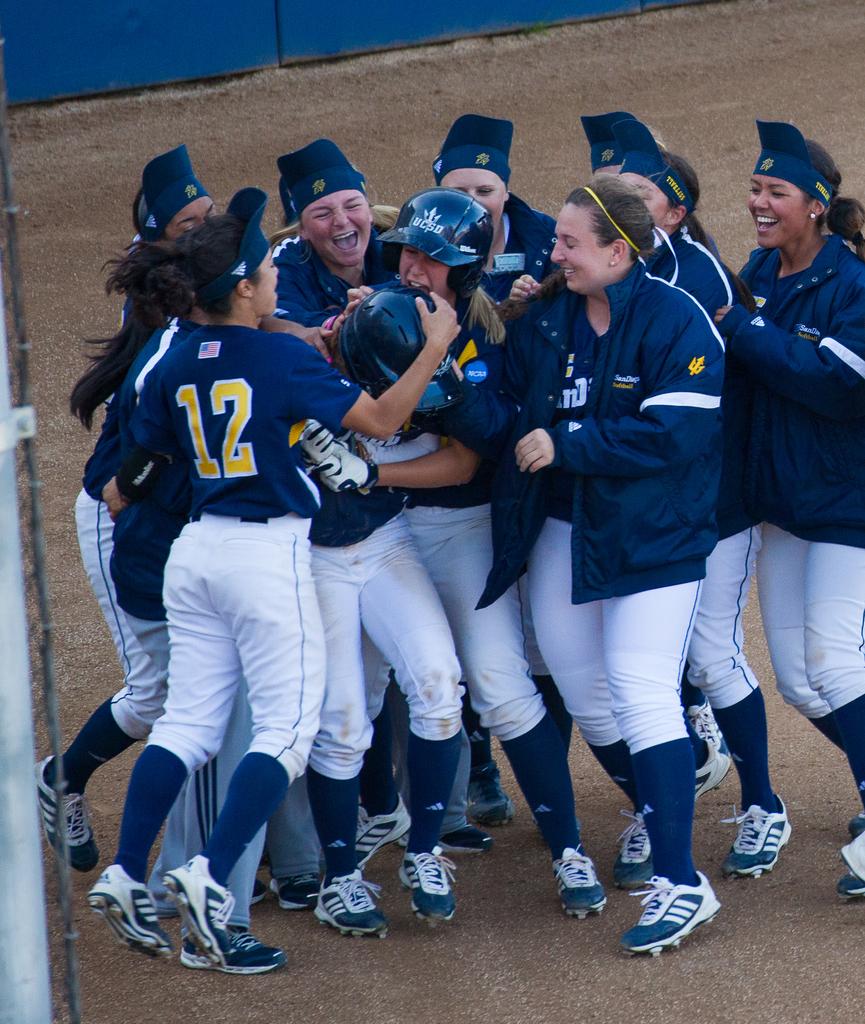What number is on the back of the shirt?
Give a very brief answer. 12. 